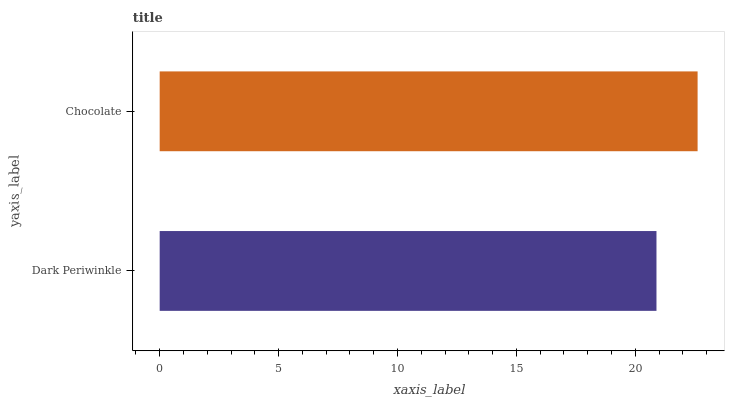Is Dark Periwinkle the minimum?
Answer yes or no. Yes. Is Chocolate the maximum?
Answer yes or no. Yes. Is Chocolate the minimum?
Answer yes or no. No. Is Chocolate greater than Dark Periwinkle?
Answer yes or no. Yes. Is Dark Periwinkle less than Chocolate?
Answer yes or no. Yes. Is Dark Periwinkle greater than Chocolate?
Answer yes or no. No. Is Chocolate less than Dark Periwinkle?
Answer yes or no. No. Is Chocolate the high median?
Answer yes or no. Yes. Is Dark Periwinkle the low median?
Answer yes or no. Yes. Is Dark Periwinkle the high median?
Answer yes or no. No. Is Chocolate the low median?
Answer yes or no. No. 